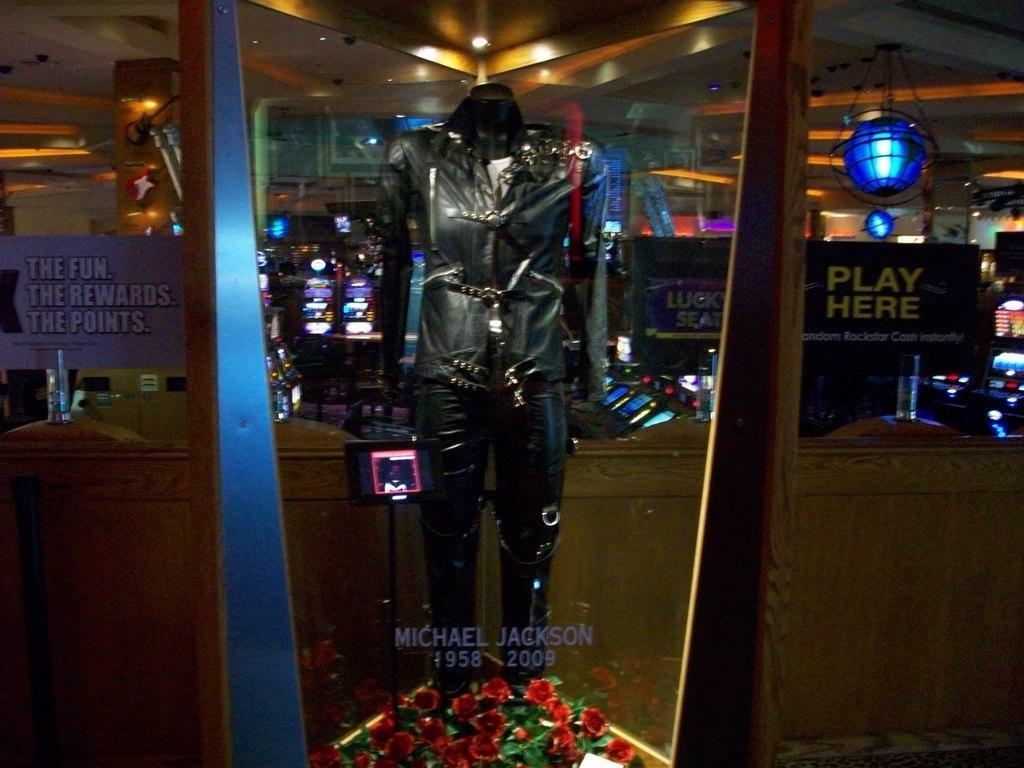Please provide a concise description of this image. In this picture we can see a mannequin, pole, screens, glass with some text on it, posters, lights, pillar and some objects. 